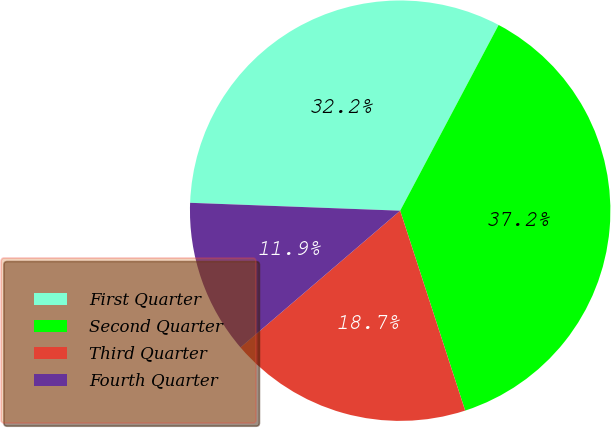<chart> <loc_0><loc_0><loc_500><loc_500><pie_chart><fcel>First Quarter<fcel>Second Quarter<fcel>Third Quarter<fcel>Fourth Quarter<nl><fcel>32.16%<fcel>37.24%<fcel>18.73%<fcel>11.87%<nl></chart> 